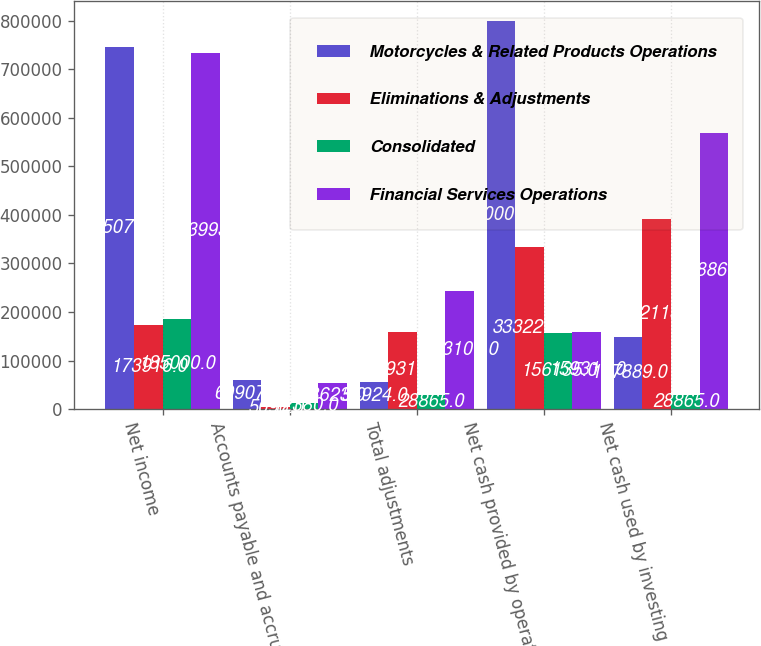Convert chart. <chart><loc_0><loc_0><loc_500><loc_500><stacked_bar_chart><ecel><fcel>Net income<fcel>Accounts payable and accrued<fcel>Total adjustments<fcel>Net cash provided by operating<fcel>Net cash used by investing<nl><fcel>Motorcycles & Related Products Operations<fcel>745077<fcel>60907<fcel>54924<fcel>800001<fcel>147889<nl><fcel>Eliminations & Adjustments<fcel>173916<fcel>5096<fcel>159311<fcel>333227<fcel>392113<nl><fcel>Consolidated<fcel>185000<fcel>12380<fcel>28865<fcel>156135<fcel>28865<nl><fcel>Financial Services Operations<fcel>733993<fcel>53623<fcel>243100<fcel>159311<fcel>568867<nl></chart> 